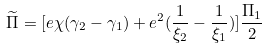<formula> <loc_0><loc_0><loc_500><loc_500>\widetilde { \Pi } = [ e \chi ( \gamma _ { 2 } - \gamma _ { 1 } ) + e ^ { 2 } ( \frac { 1 } { \xi _ { 2 } } - \frac { 1 } { \xi _ { 1 } } ) ] \frac { \Pi _ { 1 } } 2</formula> 